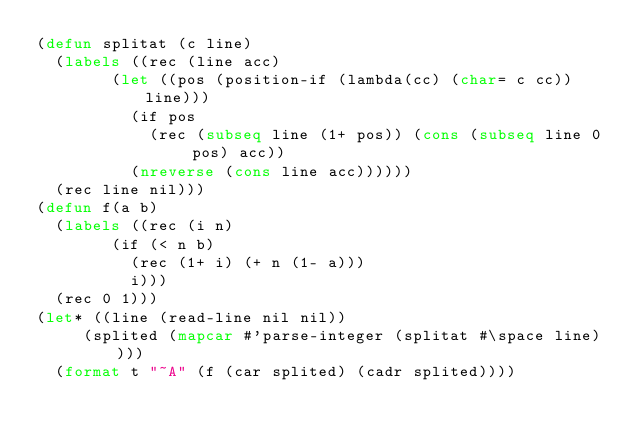Convert code to text. <code><loc_0><loc_0><loc_500><loc_500><_Lisp_>(defun splitat (c line)
  (labels ((rec (line acc)
				(let ((pos (position-if (lambda(cc) (char= c cc)) line)))
				  (if pos
					  (rec (subseq line (1+ pos)) (cons (subseq line 0 pos) acc))
					(nreverse (cons line acc))))))
	(rec line nil)))
(defun f(a b)
  (labels ((rec (i n)
				(if (< n b)
				  (rec (1+ i) (+ n (1- a)))
				  i)))
	(rec 0 1)))
(let* ((line (read-line nil nil))
	   (splited (mapcar #'parse-integer (splitat #\space line))))
  (format t "~A" (f (car splited) (cadr splited))))
</code> 